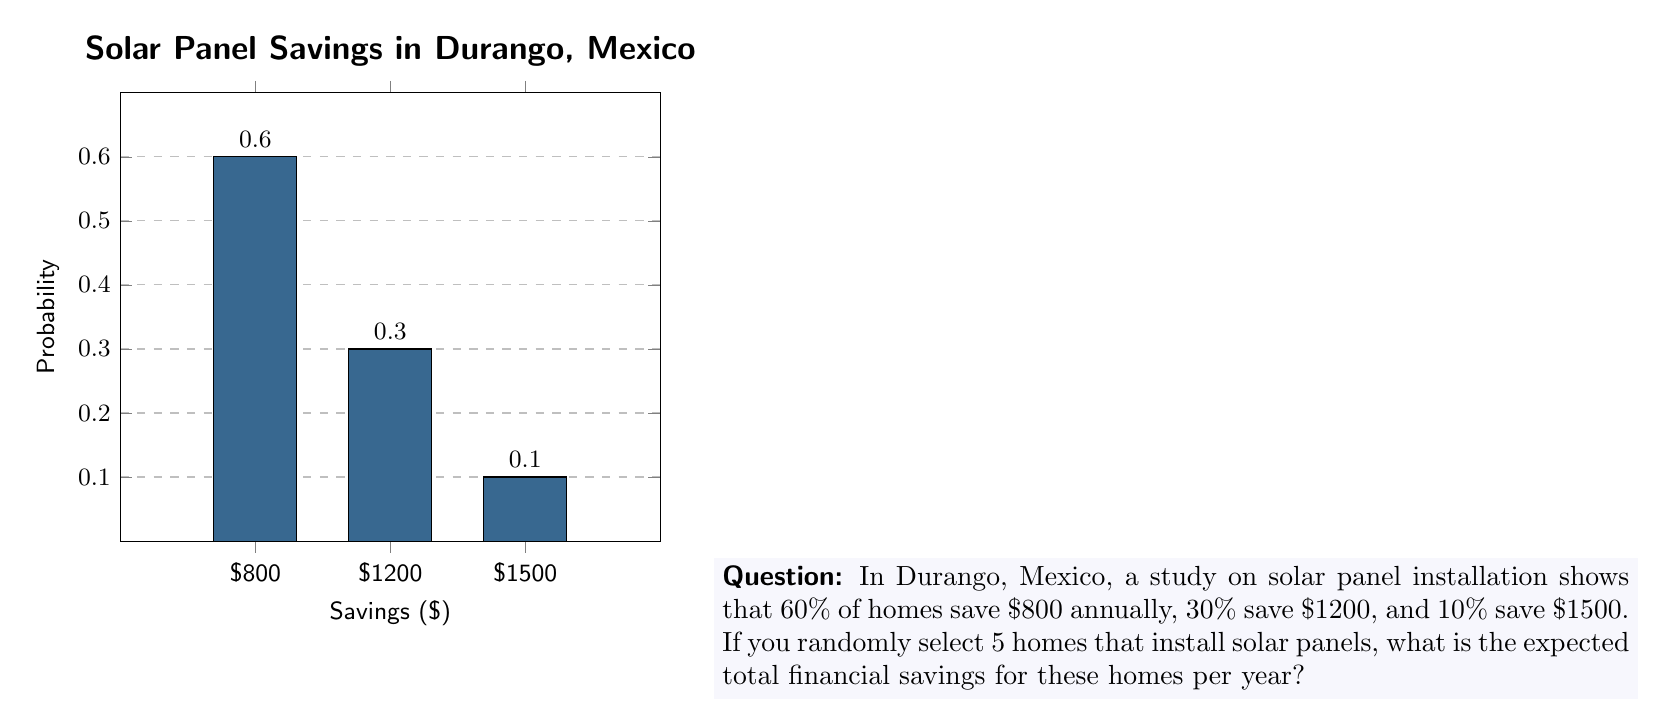Can you answer this question? To solve this problem, we need to:
1. Calculate the expected savings for one home
2. Multiply the result by 5 to get the expected savings for 5 homes

Step 1: Calculate the expected savings for one home

The expected value is the sum of each possible outcome multiplied by its probability:

$$E = \sum_{i=1}^{n} x_i \cdot p_i$$

Where $x_i$ is the savings amount and $p_i$ is the probability.

$E = 800 \cdot 0.60 + 1200 \cdot 0.30 + 1500 \cdot 0.10$
$E = 480 + 360 + 150$
$E = 990$

The expected savings for one home is $990 per year.

Step 2: Multiply by 5 for the expected savings of 5 homes

Since the question asks for 5 homes, and the savings for each home are independent, we multiply the expected value by 5:

$5 \cdot 990 = 4950$

Therefore, the expected total financial savings for 5 randomly selected homes that install solar panels is $4950 per year.
Answer: $4950 per year 